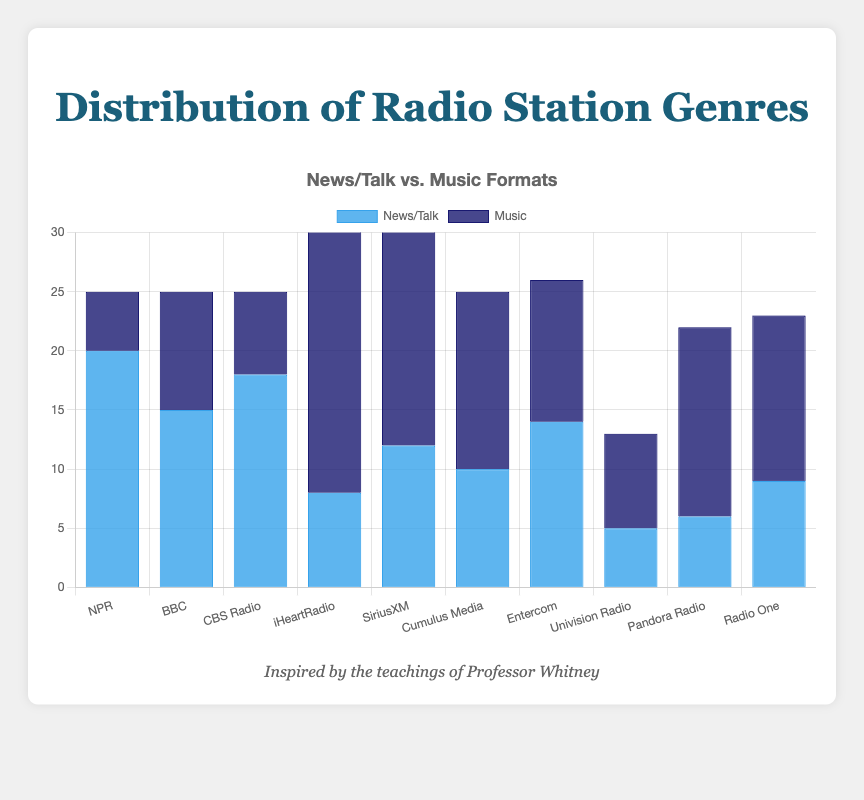Which station has the highest number of News/Talk programs? To find the station with the highest number of News/Talk programs, look at the height of the blue bars representing News/Talk categories. NPR has the tallest bar in the News/Talk category with a count of 20.
Answer: NPR Which station has the highest number of Music programs? To determine the station with the highest number of Music programs, check the height of the dark blue bars representing Music categories. iHeartRadio has the tallest bar in the Music category with a count of 25.
Answer: iHeartRadio Which station has more combined News/Talk and Music programs, SiriusXM or BBC? Add the News/Talk and Music counts for both stations. SiriusXM has 12 News/Talk and 20 Music, totaling 32. BBC has 15 News/Talk and 10 Music, totaling 25.
Answer: SiriusXM How many more Music programs does iHeartRadio have compared to CBS Radio? Subtract the number of Music programs in CBS Radio from iHeartRadio to find the difference (25 - 7).
Answer: 18 What is the ratio of News/Talk to Music programs for NPR? Divide the number of News/Talk programs by the number of Music programs for NPR (20 / 5).
Answer: 4:1 What is the difference in the number of News/Talk vs. Music programs for Cumulus Media? Subtract the number of Music programs from News/Talk programs for Cumulus Media (10 - 15).
Answer: -5 Which station has the lowest number of News/Talk programs? Look for the shortest blue bar representing News/Talk categories. Univision Radio has the shortest bar with a count of 5.
Answer: Univision Radio How many stations have more Music programs than News/Talk programs? Count the stations where the dark blue bar (Music) is taller than the blue bar (News/Talk). The stations are BBC, iHeartRadio, SiriusXM, Cumulus Media, Pandora Radio, and Radio One.
Answer: 6 What is the combined total of News/Talk programs for all stations? Add the number of News/Talk programs across all stations: 20 + 15 + 18 + 8 + 12 + 10 + 14 + 5 + 6 + 9.
Answer: 117 Which station's combined total of News/Talk and Music programs is closest to 30? Calculate the combined total for each station and compare them: NPR (25), BBC (25), CBS Radio (25), iHeartRadio (33), SiriusXM (32), Cumulus Media (25), Entercom (26), Univision Radio (13), Pandora Radio (22), Radio One (23). The closest to 30 are iHeartRadio and SiriusXM.
Answer: iHeartRadio, SiriusXM 